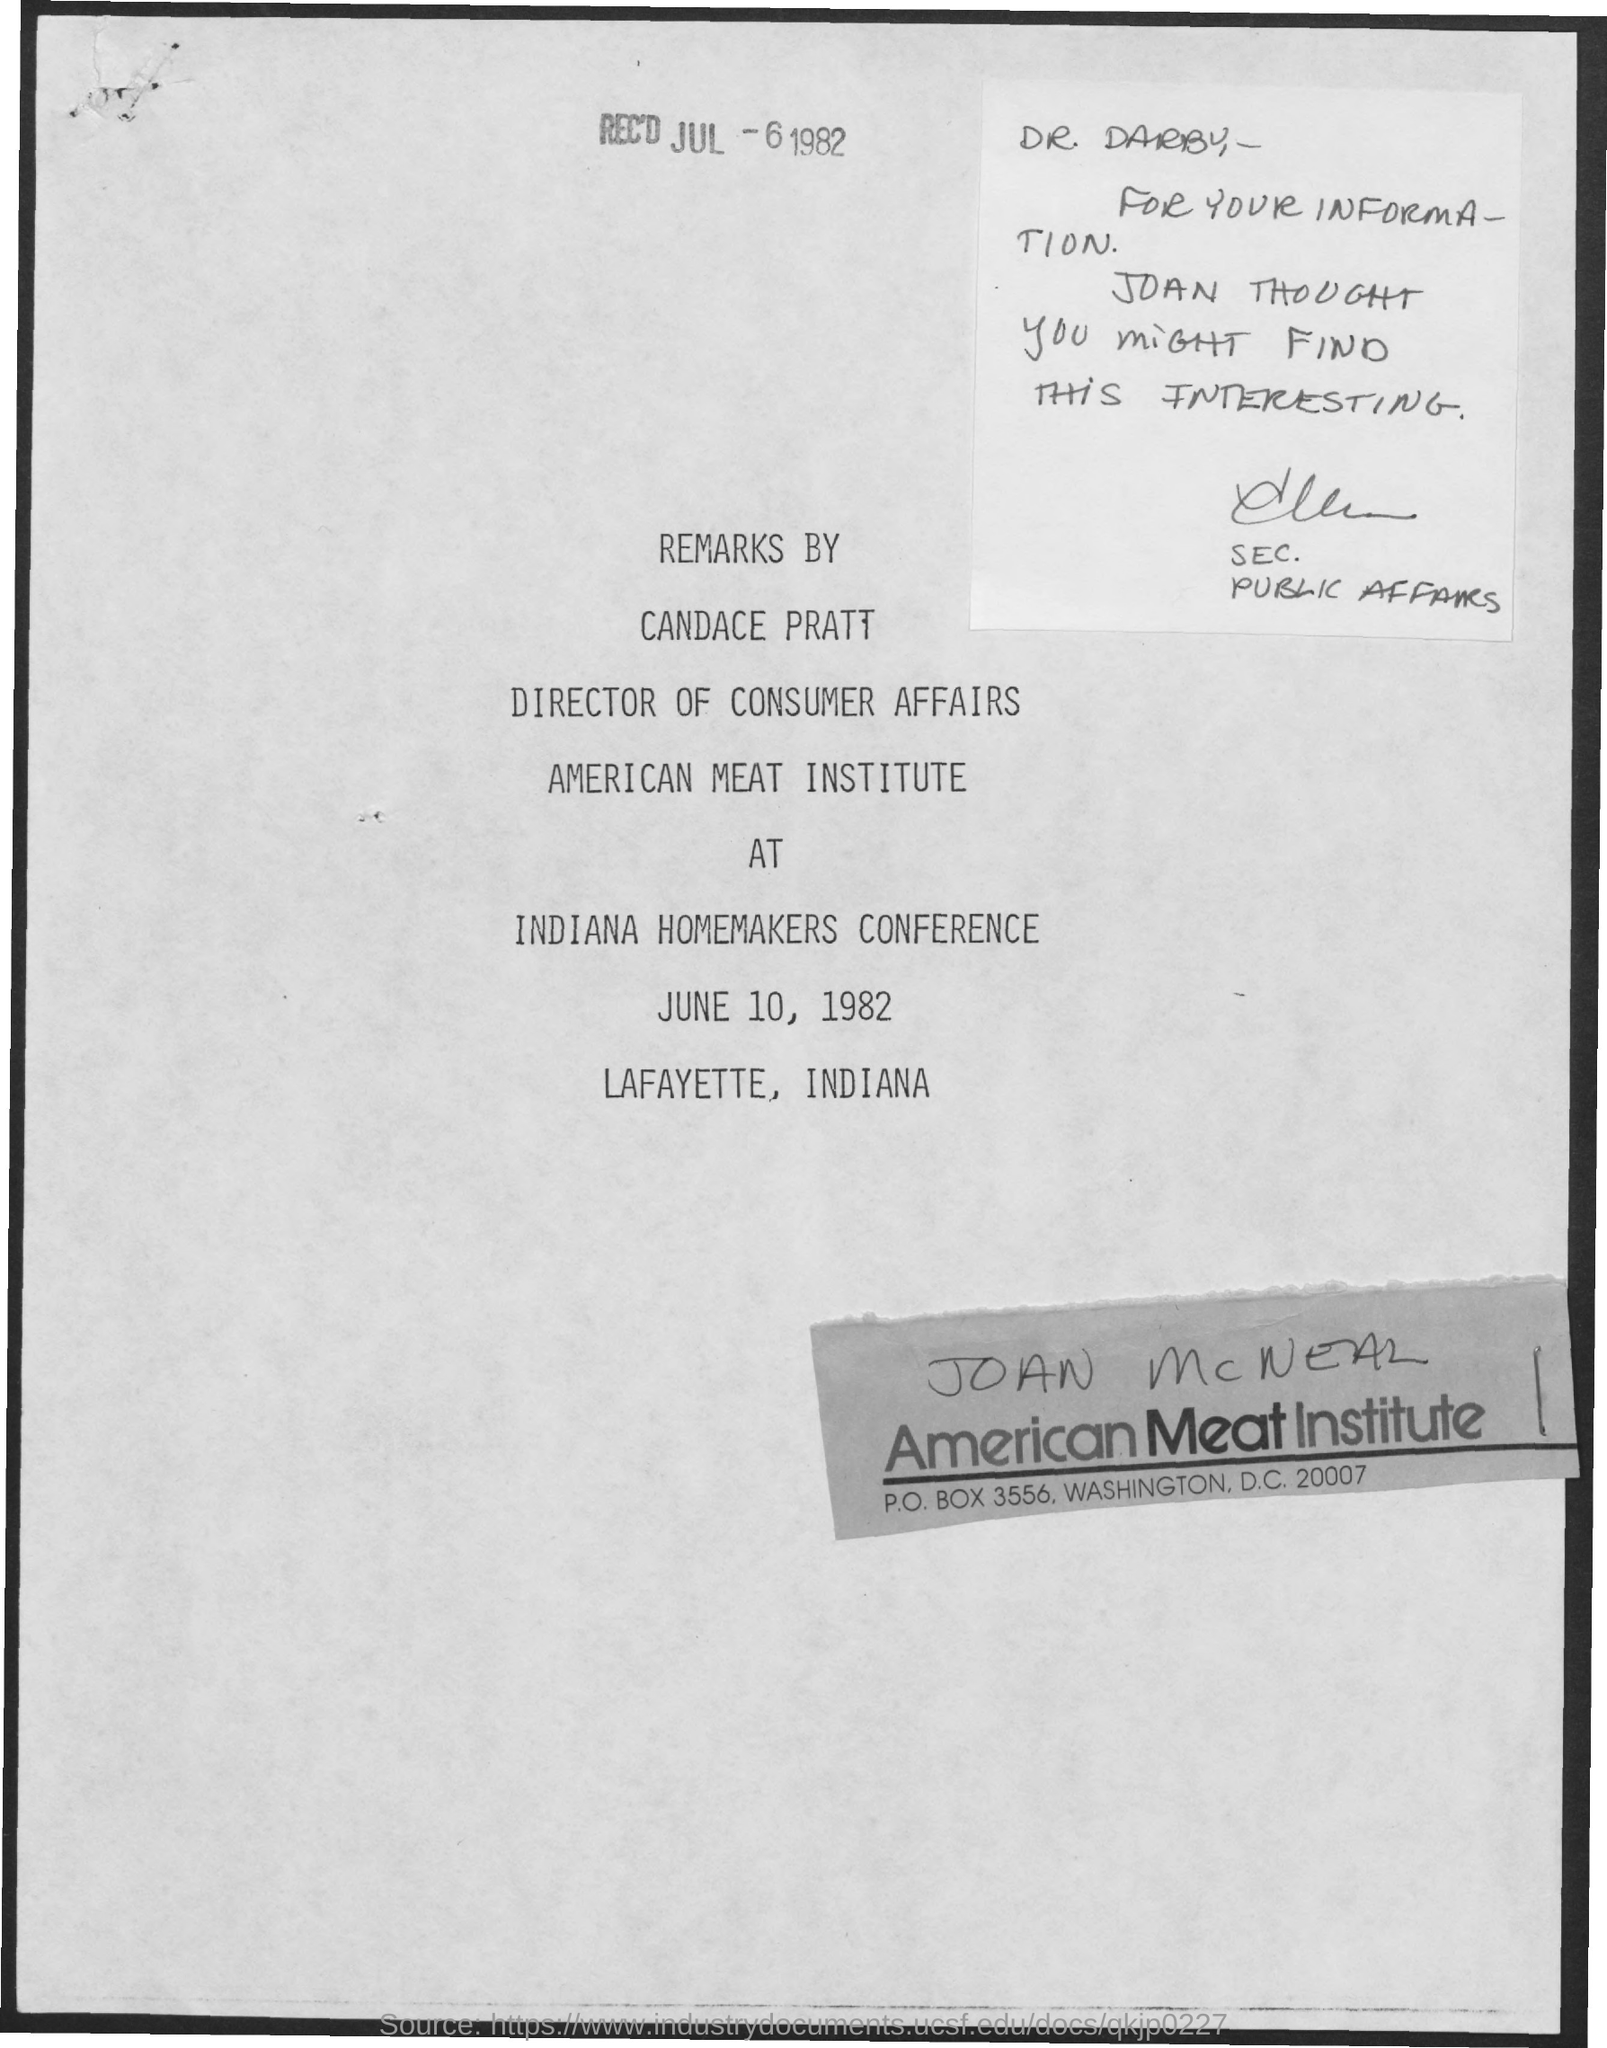When was it received?
Provide a short and direct response. JUL-6 1982. The remarks are by whom?
Offer a terse response. Candace Pratt. Which conference were the remarks given?
Your response must be concise. Indiana homemakers conference. When was the conference?
Provide a short and direct response. June 10, 1982. Where was the conference held?
Offer a very short reply. Lafayette, Indiana. To Whom is this note addressed to?
Keep it short and to the point. Dr. Darby. 